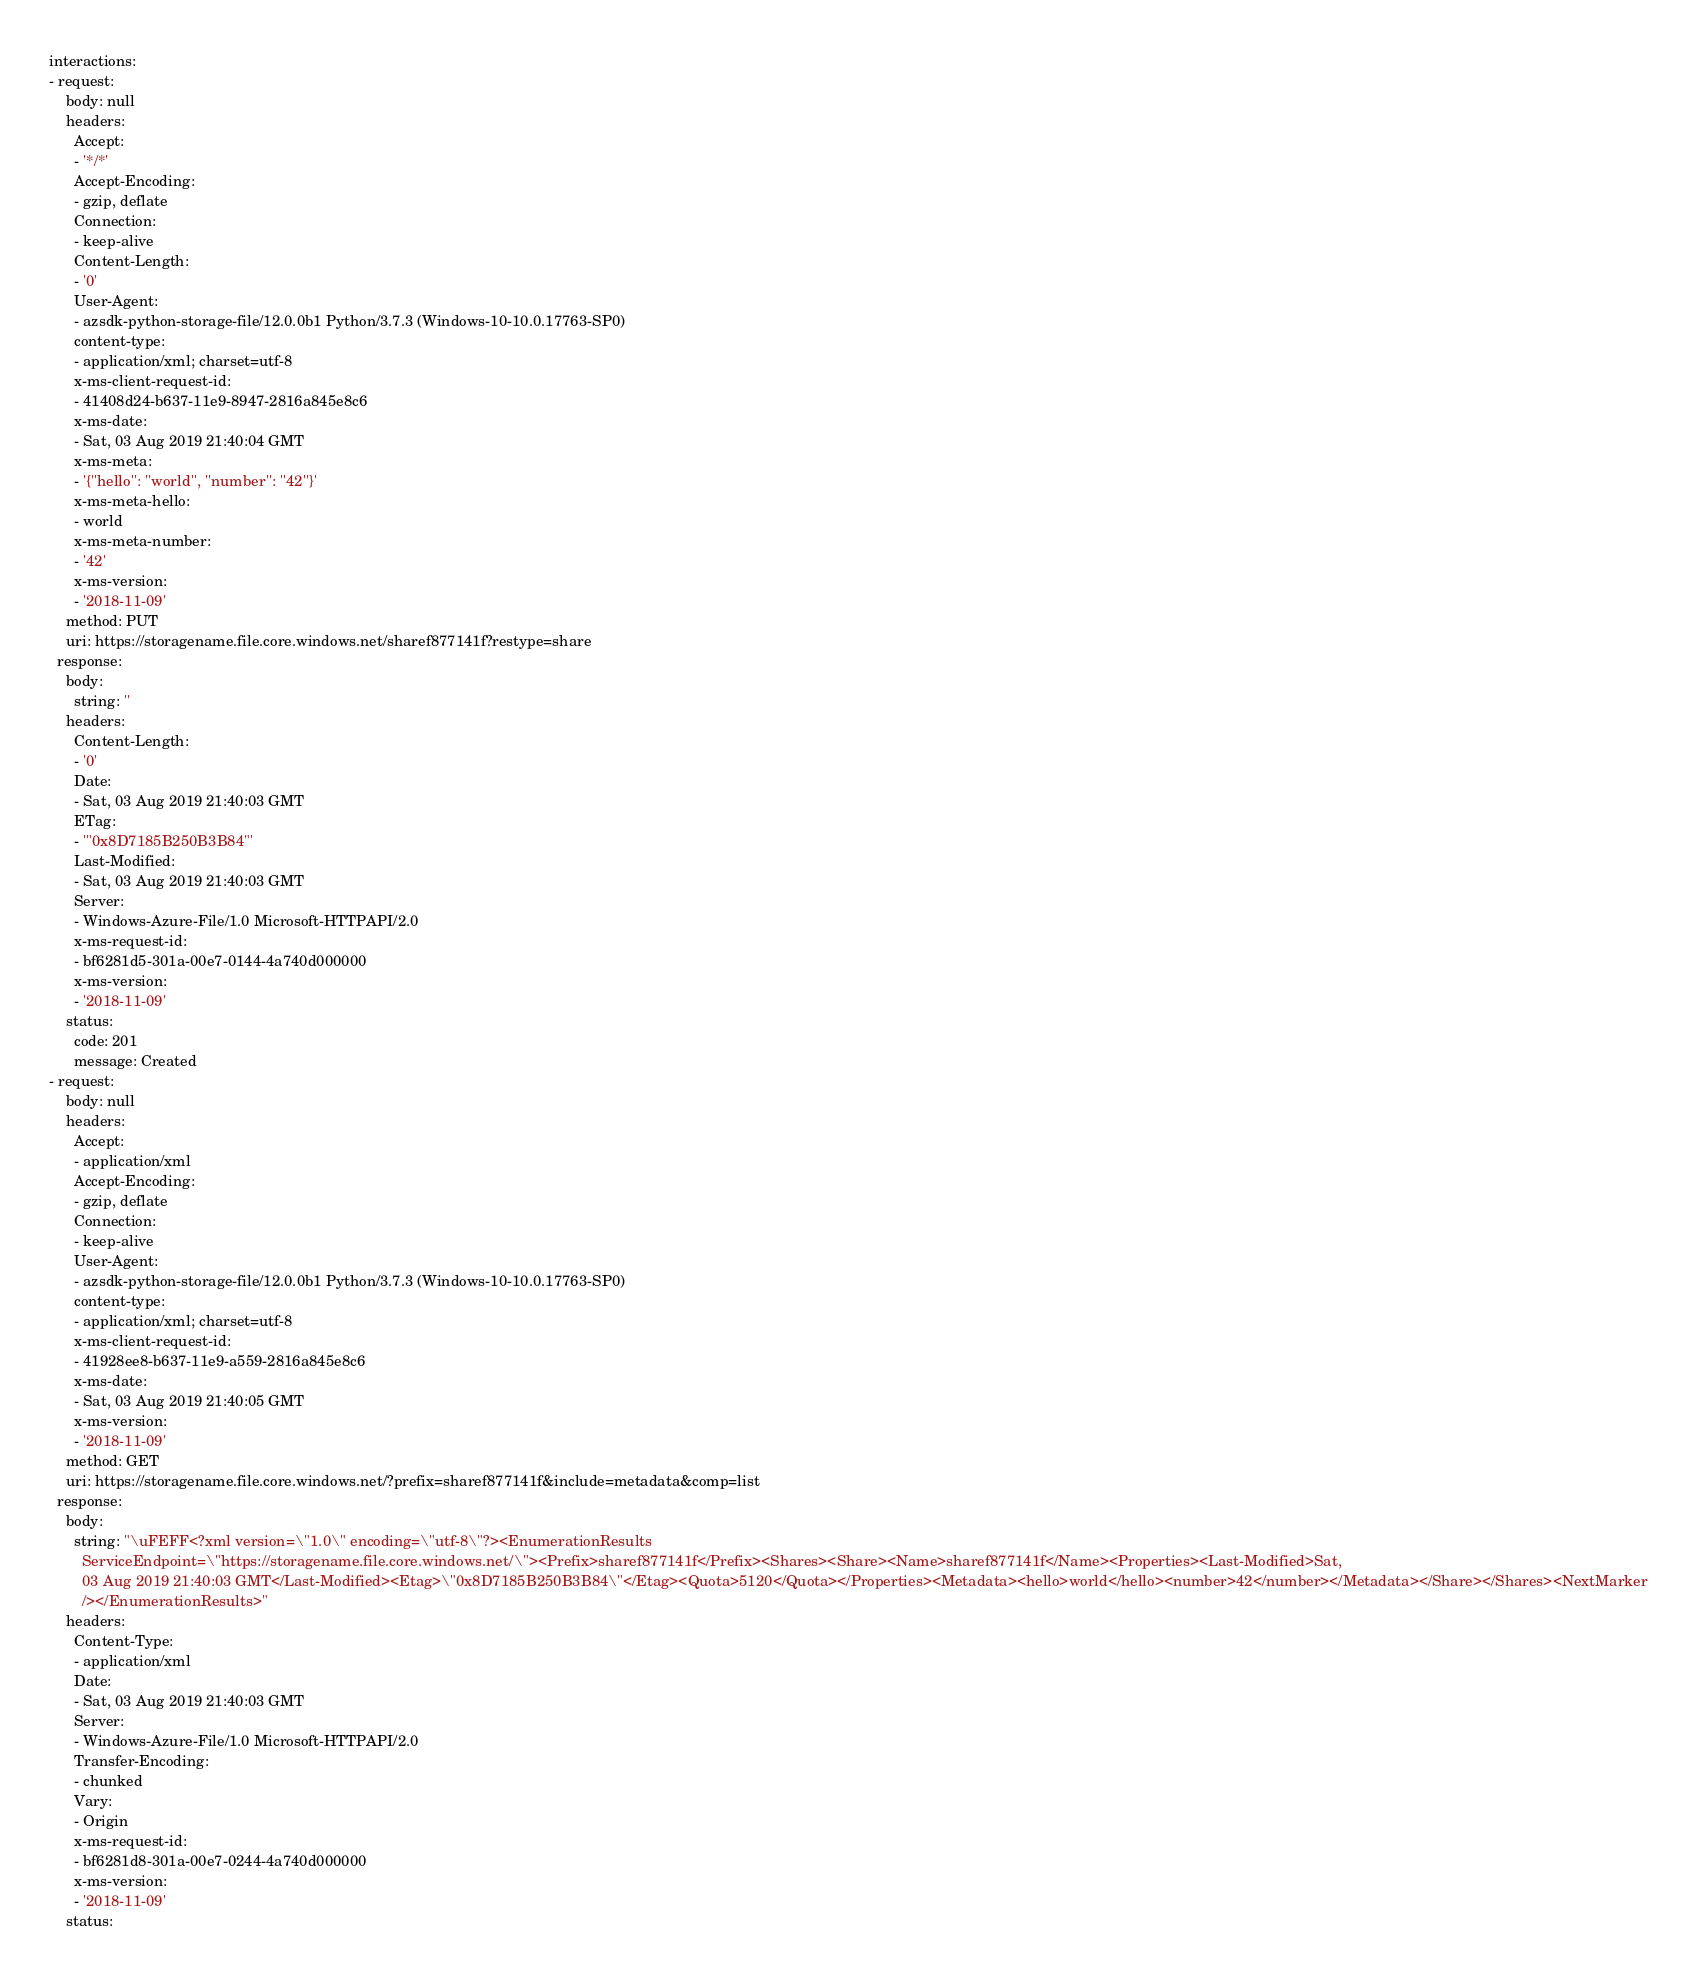Convert code to text. <code><loc_0><loc_0><loc_500><loc_500><_YAML_>interactions:
- request:
    body: null
    headers:
      Accept:
      - '*/*'
      Accept-Encoding:
      - gzip, deflate
      Connection:
      - keep-alive
      Content-Length:
      - '0'
      User-Agent:
      - azsdk-python-storage-file/12.0.0b1 Python/3.7.3 (Windows-10-10.0.17763-SP0)
      content-type:
      - application/xml; charset=utf-8
      x-ms-client-request-id:
      - 41408d24-b637-11e9-8947-2816a845e8c6
      x-ms-date:
      - Sat, 03 Aug 2019 21:40:04 GMT
      x-ms-meta:
      - '{''hello'': ''world'', ''number'': ''42''}'
      x-ms-meta-hello:
      - world
      x-ms-meta-number:
      - '42'
      x-ms-version:
      - '2018-11-09'
    method: PUT
    uri: https://storagename.file.core.windows.net/sharef877141f?restype=share
  response:
    body:
      string: ''
    headers:
      Content-Length:
      - '0'
      Date:
      - Sat, 03 Aug 2019 21:40:03 GMT
      ETag:
      - '"0x8D7185B250B3B84"'
      Last-Modified:
      - Sat, 03 Aug 2019 21:40:03 GMT
      Server:
      - Windows-Azure-File/1.0 Microsoft-HTTPAPI/2.0
      x-ms-request-id:
      - bf6281d5-301a-00e7-0144-4a740d000000
      x-ms-version:
      - '2018-11-09'
    status:
      code: 201
      message: Created
- request:
    body: null
    headers:
      Accept:
      - application/xml
      Accept-Encoding:
      - gzip, deflate
      Connection:
      - keep-alive
      User-Agent:
      - azsdk-python-storage-file/12.0.0b1 Python/3.7.3 (Windows-10-10.0.17763-SP0)
      content-type:
      - application/xml; charset=utf-8
      x-ms-client-request-id:
      - 41928ee8-b637-11e9-a559-2816a845e8c6
      x-ms-date:
      - Sat, 03 Aug 2019 21:40:05 GMT
      x-ms-version:
      - '2018-11-09'
    method: GET
    uri: https://storagename.file.core.windows.net/?prefix=sharef877141f&include=metadata&comp=list
  response:
    body:
      string: "\uFEFF<?xml version=\"1.0\" encoding=\"utf-8\"?><EnumerationResults
        ServiceEndpoint=\"https://storagename.file.core.windows.net/\"><Prefix>sharef877141f</Prefix><Shares><Share><Name>sharef877141f</Name><Properties><Last-Modified>Sat,
        03 Aug 2019 21:40:03 GMT</Last-Modified><Etag>\"0x8D7185B250B3B84\"</Etag><Quota>5120</Quota></Properties><Metadata><hello>world</hello><number>42</number></Metadata></Share></Shares><NextMarker
        /></EnumerationResults>"
    headers:
      Content-Type:
      - application/xml
      Date:
      - Sat, 03 Aug 2019 21:40:03 GMT
      Server:
      - Windows-Azure-File/1.0 Microsoft-HTTPAPI/2.0
      Transfer-Encoding:
      - chunked
      Vary:
      - Origin
      x-ms-request-id:
      - bf6281d8-301a-00e7-0244-4a740d000000
      x-ms-version:
      - '2018-11-09'
    status:</code> 